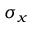<formula> <loc_0><loc_0><loc_500><loc_500>\sigma _ { x }</formula> 